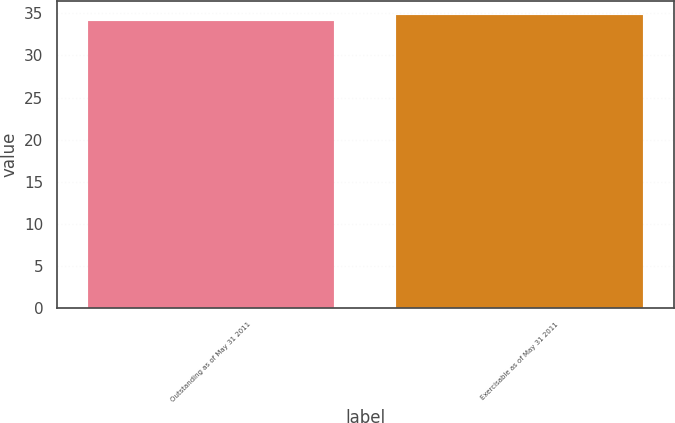Convert chart. <chart><loc_0><loc_0><loc_500><loc_500><bar_chart><fcel>Outstanding as of May 31 2011<fcel>Exercisable as of May 31 2011<nl><fcel>34.14<fcel>34.76<nl></chart> 